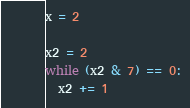<code> <loc_0><loc_0><loc_500><loc_500><_Python_>x = 2

x2 = 2
while (x2 & 7) == 0:
  x2 += 1</code> 